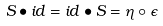<formula> <loc_0><loc_0><loc_500><loc_500>S \bullet i d = i d \bullet S = \eta \circ \epsilon</formula> 